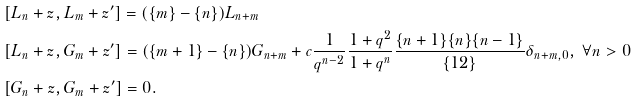Convert formula to latex. <formula><loc_0><loc_0><loc_500><loc_500>& [ L _ { n } + z , L _ { m } + z ^ { \prime } ] = ( \{ m \} - \{ n \} ) L _ { n + m } & & \\ & [ L _ { n } + z , G _ { m } + z ^ { \prime } ] = ( \{ m + 1 \} - \{ n \} ) G _ { n + m } + c \frac { 1 } { q ^ { n - 2 } } \frac { 1 + q ^ { 2 } } { 1 + q ^ { n } } \frac { \{ n + 1 \} \{ n \} \{ n - 1 \} } { \{ 1 2 \} } \delta _ { n + m , 0 } , \ \forall n > 0 \\ & [ G _ { n } + z , G _ { m } + z ^ { \prime } ] = 0 .</formula> 